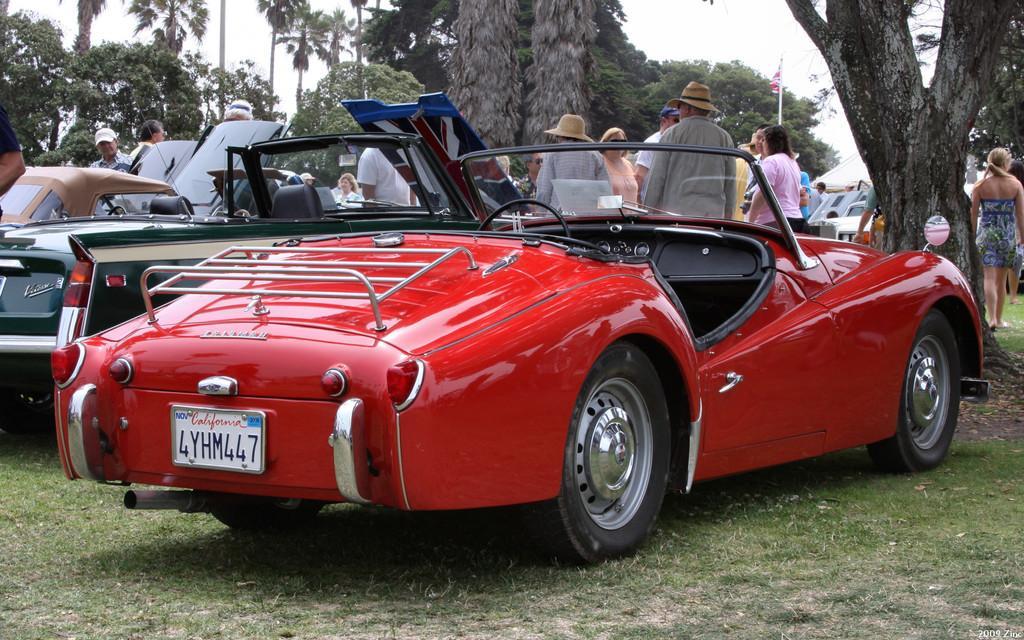Please provide a concise description of this image. In this picture we can see vehicles,people on the ground and in the background we can see trees,sky. 